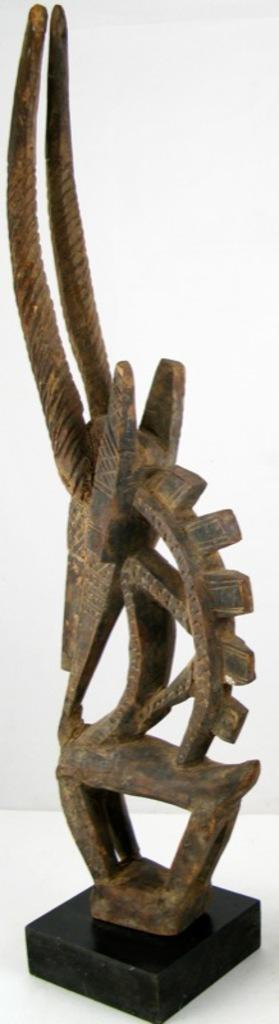What material is the object in the image made of? The object in the image is made of metal. What color is the background of the image? The background of the image is white. What type of surface is at the bottom of the image? There is a white surface at the bottom of the image. How does the son contribute to the image? There is no mention of a son or any person in the image, so it cannot be determined how a son might contribute to the image. 